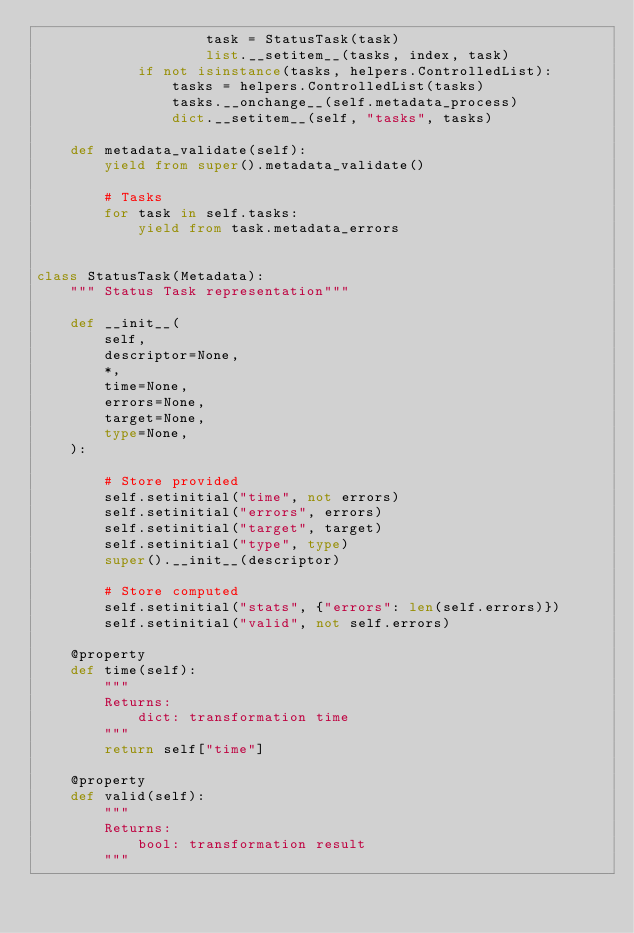<code> <loc_0><loc_0><loc_500><loc_500><_Python_>                    task = StatusTask(task)
                    list.__setitem__(tasks, index, task)
            if not isinstance(tasks, helpers.ControlledList):
                tasks = helpers.ControlledList(tasks)
                tasks.__onchange__(self.metadata_process)
                dict.__setitem__(self, "tasks", tasks)

    def metadata_validate(self):
        yield from super().metadata_validate()

        # Tasks
        for task in self.tasks:
            yield from task.metadata_errors


class StatusTask(Metadata):
    """ Status Task representation"""

    def __init__(
        self,
        descriptor=None,
        *,
        time=None,
        errors=None,
        target=None,
        type=None,
    ):

        # Store provided
        self.setinitial("time", not errors)
        self.setinitial("errors", errors)
        self.setinitial("target", target)
        self.setinitial("type", type)
        super().__init__(descriptor)

        # Store computed
        self.setinitial("stats", {"errors": len(self.errors)})
        self.setinitial("valid", not self.errors)

    @property
    def time(self):
        """
        Returns:
            dict: transformation time
        """
        return self["time"]

    @property
    def valid(self):
        """
        Returns:
            bool: transformation result
        """</code> 